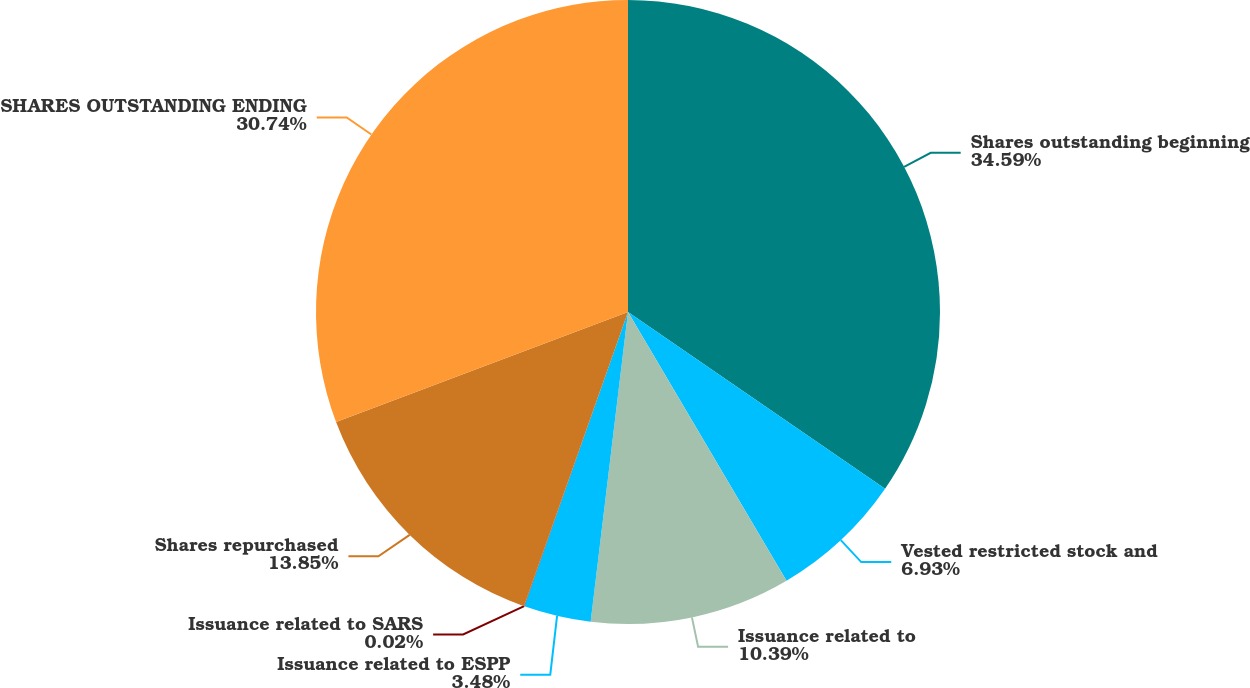Convert chart. <chart><loc_0><loc_0><loc_500><loc_500><pie_chart><fcel>Shares outstanding beginning<fcel>Vested restricted stock and<fcel>Issuance related to<fcel>Issuance related to ESPP<fcel>Issuance related to SARS<fcel>Shares repurchased<fcel>SHARES OUTSTANDING ENDING<nl><fcel>34.59%<fcel>6.93%<fcel>10.39%<fcel>3.48%<fcel>0.02%<fcel>13.85%<fcel>30.74%<nl></chart> 